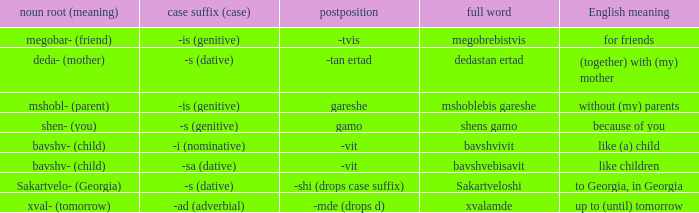In the context of "to georgia, in georgia," what is the meaning of case suffix (case)? -s (dative). 